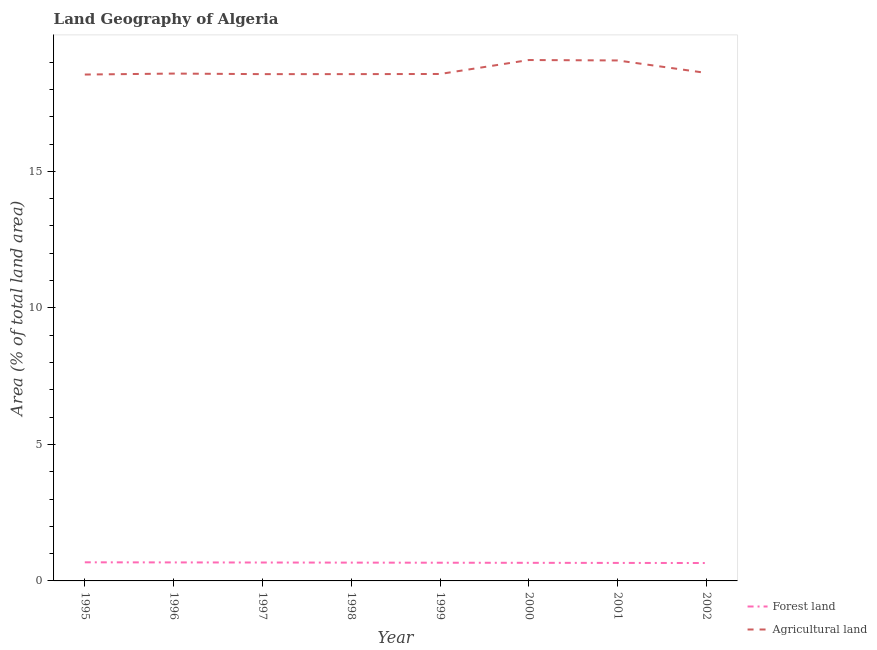Does the line corresponding to percentage of land area under agriculture intersect with the line corresponding to percentage of land area under forests?
Your answer should be very brief. No. Is the number of lines equal to the number of legend labels?
Your answer should be very brief. Yes. What is the percentage of land area under agriculture in 2002?
Give a very brief answer. 18.6. Across all years, what is the maximum percentage of land area under agriculture?
Your answer should be very brief. 19.08. Across all years, what is the minimum percentage of land area under agriculture?
Ensure brevity in your answer.  18.54. In which year was the percentage of land area under forests maximum?
Your answer should be very brief. 1995. What is the total percentage of land area under agriculture in the graph?
Your response must be concise. 149.54. What is the difference between the percentage of land area under forests in 2001 and that in 2002?
Make the answer very short. 0. What is the difference between the percentage of land area under forests in 1998 and the percentage of land area under agriculture in 1995?
Make the answer very short. -17.87. What is the average percentage of land area under agriculture per year?
Make the answer very short. 18.69. In the year 1995, what is the difference between the percentage of land area under forests and percentage of land area under agriculture?
Offer a very short reply. -17.86. What is the ratio of the percentage of land area under agriculture in 1995 to that in 2002?
Make the answer very short. 1. What is the difference between the highest and the second highest percentage of land area under agriculture?
Offer a very short reply. 0.02. What is the difference between the highest and the lowest percentage of land area under agriculture?
Make the answer very short. 0.53. In how many years, is the percentage of land area under agriculture greater than the average percentage of land area under agriculture taken over all years?
Your response must be concise. 2. Does the percentage of land area under agriculture monotonically increase over the years?
Make the answer very short. No. Is the percentage of land area under agriculture strictly greater than the percentage of land area under forests over the years?
Keep it short and to the point. Yes. What is the difference between two consecutive major ticks on the Y-axis?
Your answer should be compact. 5. Does the graph contain any zero values?
Provide a succinct answer. No. Where does the legend appear in the graph?
Offer a terse response. Bottom right. What is the title of the graph?
Your answer should be compact. Land Geography of Algeria. What is the label or title of the Y-axis?
Offer a very short reply. Area (% of total land area). What is the Area (% of total land area) in Forest land in 1995?
Make the answer very short. 0.68. What is the Area (% of total land area) of Agricultural land in 1995?
Offer a very short reply. 18.54. What is the Area (% of total land area) in Forest land in 1996?
Ensure brevity in your answer.  0.68. What is the Area (% of total land area) of Agricultural land in 1996?
Ensure brevity in your answer.  18.58. What is the Area (% of total land area) in Forest land in 1997?
Keep it short and to the point. 0.67. What is the Area (% of total land area) in Agricultural land in 1997?
Offer a very short reply. 18.56. What is the Area (% of total land area) in Forest land in 1998?
Offer a very short reply. 0.67. What is the Area (% of total land area) in Agricultural land in 1998?
Give a very brief answer. 18.56. What is the Area (% of total land area) of Forest land in 1999?
Your response must be concise. 0.67. What is the Area (% of total land area) in Agricultural land in 1999?
Provide a succinct answer. 18.56. What is the Area (% of total land area) of Forest land in 2000?
Your answer should be compact. 0.66. What is the Area (% of total land area) of Agricultural land in 2000?
Provide a succinct answer. 19.08. What is the Area (% of total land area) of Forest land in 2001?
Provide a succinct answer. 0.66. What is the Area (% of total land area) in Agricultural land in 2001?
Ensure brevity in your answer.  19.06. What is the Area (% of total land area) in Forest land in 2002?
Ensure brevity in your answer.  0.66. What is the Area (% of total land area) of Agricultural land in 2002?
Give a very brief answer. 18.6. Across all years, what is the maximum Area (% of total land area) of Forest land?
Provide a short and direct response. 0.68. Across all years, what is the maximum Area (% of total land area) of Agricultural land?
Ensure brevity in your answer.  19.08. Across all years, what is the minimum Area (% of total land area) in Forest land?
Make the answer very short. 0.66. Across all years, what is the minimum Area (% of total land area) of Agricultural land?
Provide a short and direct response. 18.54. What is the total Area (% of total land area) in Forest land in the graph?
Make the answer very short. 5.35. What is the total Area (% of total land area) in Agricultural land in the graph?
Ensure brevity in your answer.  149.54. What is the difference between the Area (% of total land area) of Forest land in 1995 and that in 1996?
Keep it short and to the point. 0. What is the difference between the Area (% of total land area) in Agricultural land in 1995 and that in 1996?
Provide a short and direct response. -0.04. What is the difference between the Area (% of total land area) in Forest land in 1995 and that in 1997?
Ensure brevity in your answer.  0.01. What is the difference between the Area (% of total land area) in Agricultural land in 1995 and that in 1997?
Make the answer very short. -0.02. What is the difference between the Area (% of total land area) in Forest land in 1995 and that in 1998?
Your response must be concise. 0.01. What is the difference between the Area (% of total land area) of Agricultural land in 1995 and that in 1998?
Make the answer very short. -0.02. What is the difference between the Area (% of total land area) in Forest land in 1995 and that in 1999?
Your response must be concise. 0.01. What is the difference between the Area (% of total land area) of Agricultural land in 1995 and that in 1999?
Your answer should be very brief. -0.02. What is the difference between the Area (% of total land area) of Forest land in 1995 and that in 2000?
Offer a terse response. 0.02. What is the difference between the Area (% of total land area) of Agricultural land in 1995 and that in 2000?
Keep it short and to the point. -0.53. What is the difference between the Area (% of total land area) of Forest land in 1995 and that in 2001?
Your response must be concise. 0.02. What is the difference between the Area (% of total land area) in Agricultural land in 1995 and that in 2001?
Your response must be concise. -0.52. What is the difference between the Area (% of total land area) in Forest land in 1995 and that in 2002?
Offer a very short reply. 0.03. What is the difference between the Area (% of total land area) of Agricultural land in 1995 and that in 2002?
Offer a terse response. -0.06. What is the difference between the Area (% of total land area) in Forest land in 1996 and that in 1997?
Offer a terse response. 0. What is the difference between the Area (% of total land area) of Agricultural land in 1996 and that in 1997?
Ensure brevity in your answer.  0.02. What is the difference between the Area (% of total land area) in Forest land in 1996 and that in 1998?
Make the answer very short. 0.01. What is the difference between the Area (% of total land area) in Agricultural land in 1996 and that in 1998?
Offer a very short reply. 0.02. What is the difference between the Area (% of total land area) in Forest land in 1996 and that in 1999?
Ensure brevity in your answer.  0.01. What is the difference between the Area (% of total land area) in Agricultural land in 1996 and that in 1999?
Offer a very short reply. 0.01. What is the difference between the Area (% of total land area) of Forest land in 1996 and that in 2000?
Make the answer very short. 0.01. What is the difference between the Area (% of total land area) of Agricultural land in 1996 and that in 2000?
Keep it short and to the point. -0.5. What is the difference between the Area (% of total land area) in Forest land in 1996 and that in 2001?
Keep it short and to the point. 0.02. What is the difference between the Area (% of total land area) of Agricultural land in 1996 and that in 2001?
Provide a short and direct response. -0.48. What is the difference between the Area (% of total land area) in Forest land in 1996 and that in 2002?
Your response must be concise. 0.02. What is the difference between the Area (% of total land area) in Agricultural land in 1996 and that in 2002?
Provide a succinct answer. -0.02. What is the difference between the Area (% of total land area) in Forest land in 1997 and that in 1998?
Offer a very short reply. 0. What is the difference between the Area (% of total land area) in Forest land in 1997 and that in 1999?
Ensure brevity in your answer.  0.01. What is the difference between the Area (% of total land area) of Agricultural land in 1997 and that in 1999?
Your answer should be compact. -0.01. What is the difference between the Area (% of total land area) in Forest land in 1997 and that in 2000?
Provide a succinct answer. 0.01. What is the difference between the Area (% of total land area) in Agricultural land in 1997 and that in 2000?
Offer a terse response. -0.52. What is the difference between the Area (% of total land area) of Forest land in 1997 and that in 2001?
Ensure brevity in your answer.  0.01. What is the difference between the Area (% of total land area) in Agricultural land in 1997 and that in 2001?
Your answer should be very brief. -0.5. What is the difference between the Area (% of total land area) in Forest land in 1997 and that in 2002?
Your answer should be compact. 0.02. What is the difference between the Area (% of total land area) of Agricultural land in 1997 and that in 2002?
Ensure brevity in your answer.  -0.04. What is the difference between the Area (% of total land area) of Forest land in 1998 and that in 1999?
Your response must be concise. 0. What is the difference between the Area (% of total land area) in Agricultural land in 1998 and that in 1999?
Your answer should be compact. -0.01. What is the difference between the Area (% of total land area) of Forest land in 1998 and that in 2000?
Offer a very short reply. 0.01. What is the difference between the Area (% of total land area) in Agricultural land in 1998 and that in 2000?
Give a very brief answer. -0.52. What is the difference between the Area (% of total land area) of Forest land in 1998 and that in 2001?
Make the answer very short. 0.01. What is the difference between the Area (% of total land area) in Agricultural land in 1998 and that in 2001?
Your answer should be very brief. -0.5. What is the difference between the Area (% of total land area) of Forest land in 1998 and that in 2002?
Keep it short and to the point. 0.01. What is the difference between the Area (% of total land area) of Agricultural land in 1998 and that in 2002?
Provide a succinct answer. -0.04. What is the difference between the Area (% of total land area) in Forest land in 1999 and that in 2000?
Your answer should be compact. 0. What is the difference between the Area (% of total land area) of Agricultural land in 1999 and that in 2000?
Make the answer very short. -0.51. What is the difference between the Area (% of total land area) of Forest land in 1999 and that in 2001?
Your answer should be very brief. 0.01. What is the difference between the Area (% of total land area) of Agricultural land in 1999 and that in 2001?
Provide a succinct answer. -0.5. What is the difference between the Area (% of total land area) in Forest land in 1999 and that in 2002?
Your answer should be very brief. 0.01. What is the difference between the Area (% of total land area) in Agricultural land in 1999 and that in 2002?
Your answer should be compact. -0.04. What is the difference between the Area (% of total land area) in Forest land in 2000 and that in 2001?
Provide a short and direct response. 0. What is the difference between the Area (% of total land area) of Agricultural land in 2000 and that in 2001?
Offer a very short reply. 0.02. What is the difference between the Area (% of total land area) of Forest land in 2000 and that in 2002?
Your answer should be very brief. 0.01. What is the difference between the Area (% of total land area) in Agricultural land in 2000 and that in 2002?
Keep it short and to the point. 0.47. What is the difference between the Area (% of total land area) in Forest land in 2001 and that in 2002?
Keep it short and to the point. 0. What is the difference between the Area (% of total land area) of Agricultural land in 2001 and that in 2002?
Your answer should be very brief. 0.46. What is the difference between the Area (% of total land area) of Forest land in 1995 and the Area (% of total land area) of Agricultural land in 1996?
Offer a very short reply. -17.9. What is the difference between the Area (% of total land area) of Forest land in 1995 and the Area (% of total land area) of Agricultural land in 1997?
Provide a succinct answer. -17.88. What is the difference between the Area (% of total land area) of Forest land in 1995 and the Area (% of total land area) of Agricultural land in 1998?
Make the answer very short. -17.88. What is the difference between the Area (% of total land area) of Forest land in 1995 and the Area (% of total land area) of Agricultural land in 1999?
Offer a terse response. -17.88. What is the difference between the Area (% of total land area) in Forest land in 1995 and the Area (% of total land area) in Agricultural land in 2000?
Provide a short and direct response. -18.39. What is the difference between the Area (% of total land area) of Forest land in 1995 and the Area (% of total land area) of Agricultural land in 2001?
Ensure brevity in your answer.  -18.38. What is the difference between the Area (% of total land area) in Forest land in 1995 and the Area (% of total land area) in Agricultural land in 2002?
Your answer should be very brief. -17.92. What is the difference between the Area (% of total land area) of Forest land in 1996 and the Area (% of total land area) of Agricultural land in 1997?
Provide a short and direct response. -17.88. What is the difference between the Area (% of total land area) in Forest land in 1996 and the Area (% of total land area) in Agricultural land in 1998?
Provide a succinct answer. -17.88. What is the difference between the Area (% of total land area) in Forest land in 1996 and the Area (% of total land area) in Agricultural land in 1999?
Provide a short and direct response. -17.89. What is the difference between the Area (% of total land area) in Forest land in 1996 and the Area (% of total land area) in Agricultural land in 2000?
Keep it short and to the point. -18.4. What is the difference between the Area (% of total land area) of Forest land in 1996 and the Area (% of total land area) of Agricultural land in 2001?
Your answer should be compact. -18.38. What is the difference between the Area (% of total land area) of Forest land in 1996 and the Area (% of total land area) of Agricultural land in 2002?
Provide a short and direct response. -17.92. What is the difference between the Area (% of total land area) of Forest land in 1997 and the Area (% of total land area) of Agricultural land in 1998?
Provide a succinct answer. -17.89. What is the difference between the Area (% of total land area) of Forest land in 1997 and the Area (% of total land area) of Agricultural land in 1999?
Your answer should be compact. -17.89. What is the difference between the Area (% of total land area) in Forest land in 1997 and the Area (% of total land area) in Agricultural land in 2000?
Provide a short and direct response. -18.4. What is the difference between the Area (% of total land area) of Forest land in 1997 and the Area (% of total land area) of Agricultural land in 2001?
Your response must be concise. -18.39. What is the difference between the Area (% of total land area) in Forest land in 1997 and the Area (% of total land area) in Agricultural land in 2002?
Provide a succinct answer. -17.93. What is the difference between the Area (% of total land area) in Forest land in 1998 and the Area (% of total land area) in Agricultural land in 1999?
Make the answer very short. -17.89. What is the difference between the Area (% of total land area) in Forest land in 1998 and the Area (% of total land area) in Agricultural land in 2000?
Make the answer very short. -18.41. What is the difference between the Area (% of total land area) of Forest land in 1998 and the Area (% of total land area) of Agricultural land in 2001?
Offer a very short reply. -18.39. What is the difference between the Area (% of total land area) in Forest land in 1998 and the Area (% of total land area) in Agricultural land in 2002?
Provide a short and direct response. -17.93. What is the difference between the Area (% of total land area) of Forest land in 1999 and the Area (% of total land area) of Agricultural land in 2000?
Provide a short and direct response. -18.41. What is the difference between the Area (% of total land area) of Forest land in 1999 and the Area (% of total land area) of Agricultural land in 2001?
Your response must be concise. -18.39. What is the difference between the Area (% of total land area) of Forest land in 1999 and the Area (% of total land area) of Agricultural land in 2002?
Offer a very short reply. -17.93. What is the difference between the Area (% of total land area) in Forest land in 2000 and the Area (% of total land area) in Agricultural land in 2001?
Provide a succinct answer. -18.4. What is the difference between the Area (% of total land area) in Forest land in 2000 and the Area (% of total land area) in Agricultural land in 2002?
Offer a terse response. -17.94. What is the difference between the Area (% of total land area) in Forest land in 2001 and the Area (% of total land area) in Agricultural land in 2002?
Your answer should be compact. -17.94. What is the average Area (% of total land area) of Forest land per year?
Offer a terse response. 0.67. What is the average Area (% of total land area) of Agricultural land per year?
Offer a terse response. 18.69. In the year 1995, what is the difference between the Area (% of total land area) of Forest land and Area (% of total land area) of Agricultural land?
Offer a very short reply. -17.86. In the year 1996, what is the difference between the Area (% of total land area) in Forest land and Area (% of total land area) in Agricultural land?
Offer a terse response. -17.9. In the year 1997, what is the difference between the Area (% of total land area) in Forest land and Area (% of total land area) in Agricultural land?
Offer a very short reply. -17.89. In the year 1998, what is the difference between the Area (% of total land area) in Forest land and Area (% of total land area) in Agricultural land?
Ensure brevity in your answer.  -17.89. In the year 1999, what is the difference between the Area (% of total land area) of Forest land and Area (% of total land area) of Agricultural land?
Give a very brief answer. -17.9. In the year 2000, what is the difference between the Area (% of total land area) of Forest land and Area (% of total land area) of Agricultural land?
Give a very brief answer. -18.41. In the year 2001, what is the difference between the Area (% of total land area) of Forest land and Area (% of total land area) of Agricultural land?
Offer a very short reply. -18.4. In the year 2002, what is the difference between the Area (% of total land area) of Forest land and Area (% of total land area) of Agricultural land?
Your response must be concise. -17.95. What is the ratio of the Area (% of total land area) in Forest land in 1995 to that in 1997?
Your response must be concise. 1.01. What is the ratio of the Area (% of total land area) of Forest land in 1995 to that in 1998?
Your answer should be very brief. 1.02. What is the ratio of the Area (% of total land area) of Forest land in 1995 to that in 1999?
Give a very brief answer. 1.02. What is the ratio of the Area (% of total land area) in Forest land in 1995 to that in 2000?
Offer a terse response. 1.03. What is the ratio of the Area (% of total land area) of Agricultural land in 1995 to that in 2000?
Your response must be concise. 0.97. What is the ratio of the Area (% of total land area) of Forest land in 1995 to that in 2001?
Your answer should be compact. 1.03. What is the ratio of the Area (% of total land area) of Agricultural land in 1995 to that in 2001?
Your response must be concise. 0.97. What is the ratio of the Area (% of total land area) of Forest land in 1995 to that in 2002?
Make the answer very short. 1.04. What is the ratio of the Area (% of total land area) in Forest land in 1996 to that in 1997?
Ensure brevity in your answer.  1.01. What is the ratio of the Area (% of total land area) in Agricultural land in 1996 to that in 1997?
Provide a succinct answer. 1. What is the ratio of the Area (% of total land area) in Forest land in 1996 to that in 1998?
Make the answer very short. 1.01. What is the ratio of the Area (% of total land area) in Forest land in 1996 to that in 1999?
Offer a very short reply. 1.02. What is the ratio of the Area (% of total land area) in Forest land in 1996 to that in 2000?
Keep it short and to the point. 1.02. What is the ratio of the Area (% of total land area) of Forest land in 1996 to that in 2001?
Ensure brevity in your answer.  1.03. What is the ratio of the Area (% of total land area) in Agricultural land in 1996 to that in 2001?
Provide a succinct answer. 0.97. What is the ratio of the Area (% of total land area) in Forest land in 1996 to that in 2002?
Provide a succinct answer. 1.03. What is the ratio of the Area (% of total land area) in Agricultural land in 1996 to that in 2002?
Make the answer very short. 1. What is the ratio of the Area (% of total land area) in Forest land in 1997 to that in 1999?
Keep it short and to the point. 1.01. What is the ratio of the Area (% of total land area) in Agricultural land in 1997 to that in 1999?
Your answer should be very brief. 1. What is the ratio of the Area (% of total land area) of Forest land in 1997 to that in 2000?
Your response must be concise. 1.02. What is the ratio of the Area (% of total land area) of Agricultural land in 1997 to that in 2000?
Offer a very short reply. 0.97. What is the ratio of the Area (% of total land area) of Forest land in 1997 to that in 2001?
Provide a short and direct response. 1.02. What is the ratio of the Area (% of total land area) in Agricultural land in 1997 to that in 2001?
Offer a terse response. 0.97. What is the ratio of the Area (% of total land area) in Forest land in 1997 to that in 2002?
Your response must be concise. 1.03. What is the ratio of the Area (% of total land area) of Forest land in 1998 to that in 2000?
Provide a succinct answer. 1.01. What is the ratio of the Area (% of total land area) in Agricultural land in 1998 to that in 2000?
Give a very brief answer. 0.97. What is the ratio of the Area (% of total land area) in Forest land in 1998 to that in 2001?
Give a very brief answer. 1.02. What is the ratio of the Area (% of total land area) in Agricultural land in 1998 to that in 2001?
Your answer should be very brief. 0.97. What is the ratio of the Area (% of total land area) in Forest land in 1998 to that in 2002?
Offer a terse response. 1.02. What is the ratio of the Area (% of total land area) of Forest land in 1999 to that in 2000?
Offer a very short reply. 1.01. What is the ratio of the Area (% of total land area) of Agricultural land in 1999 to that in 2000?
Provide a succinct answer. 0.97. What is the ratio of the Area (% of total land area) in Forest land in 1999 to that in 2001?
Give a very brief answer. 1.01. What is the ratio of the Area (% of total land area) in Forest land in 1999 to that in 2002?
Your answer should be compact. 1.02. What is the ratio of the Area (% of total land area) of Agricultural land in 1999 to that in 2002?
Your response must be concise. 1. What is the ratio of the Area (% of total land area) in Agricultural land in 2000 to that in 2002?
Provide a short and direct response. 1.03. What is the ratio of the Area (% of total land area) of Forest land in 2001 to that in 2002?
Your answer should be very brief. 1.01. What is the ratio of the Area (% of total land area) in Agricultural land in 2001 to that in 2002?
Provide a succinct answer. 1.02. What is the difference between the highest and the second highest Area (% of total land area) in Forest land?
Offer a terse response. 0. What is the difference between the highest and the second highest Area (% of total land area) of Agricultural land?
Keep it short and to the point. 0.02. What is the difference between the highest and the lowest Area (% of total land area) of Forest land?
Your response must be concise. 0.03. What is the difference between the highest and the lowest Area (% of total land area) of Agricultural land?
Ensure brevity in your answer.  0.53. 